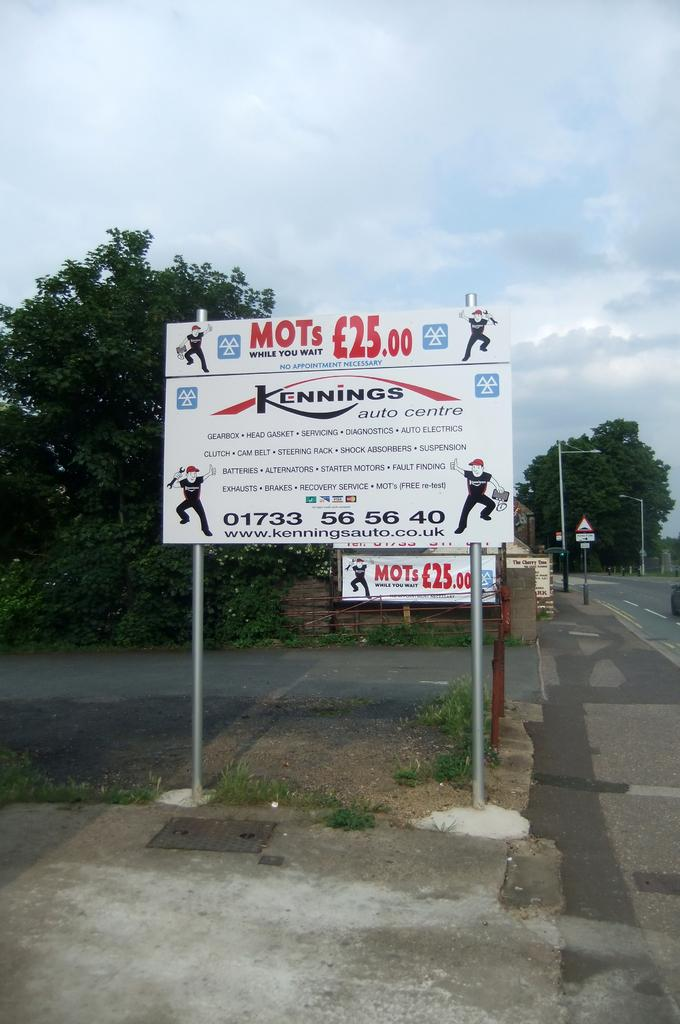<image>
Provide a brief description of the given image. A larg white sign that has the Kennings logo on it. 